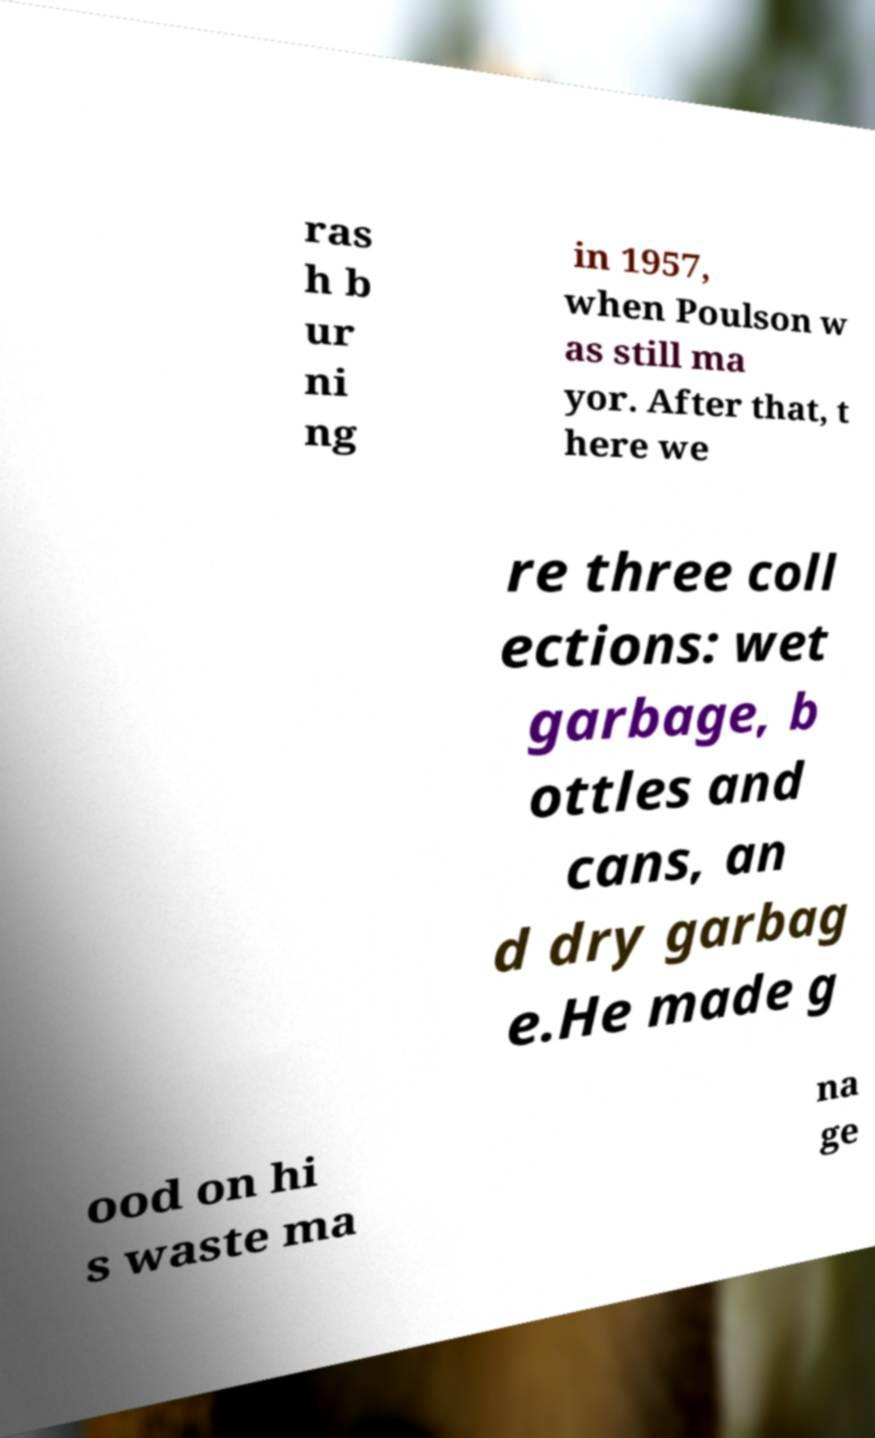There's text embedded in this image that I need extracted. Can you transcribe it verbatim? ras h b ur ni ng in 1957, when Poulson w as still ma yor. After that, t here we re three coll ections: wet garbage, b ottles and cans, an d dry garbag e.He made g ood on hi s waste ma na ge 